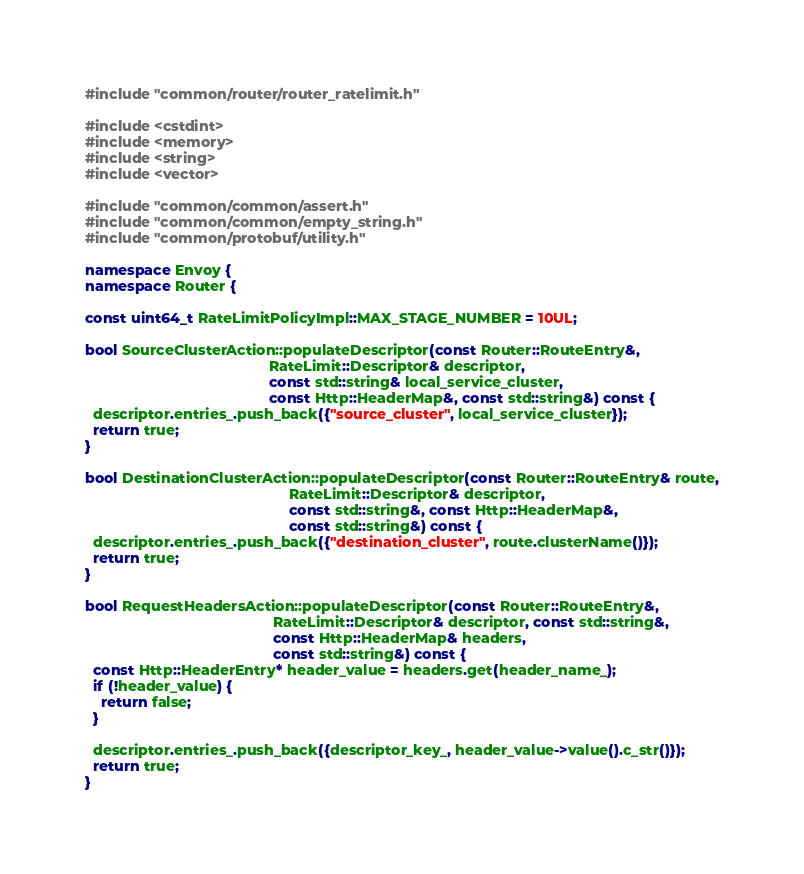Convert code to text. <code><loc_0><loc_0><loc_500><loc_500><_C++_>#include "common/router/router_ratelimit.h"

#include <cstdint>
#include <memory>
#include <string>
#include <vector>

#include "common/common/assert.h"
#include "common/common/empty_string.h"
#include "common/protobuf/utility.h"

namespace Envoy {
namespace Router {

const uint64_t RateLimitPolicyImpl::MAX_STAGE_NUMBER = 10UL;

bool SourceClusterAction::populateDescriptor(const Router::RouteEntry&,
                                             RateLimit::Descriptor& descriptor,
                                             const std::string& local_service_cluster,
                                             const Http::HeaderMap&, const std::string&) const {
  descriptor.entries_.push_back({"source_cluster", local_service_cluster});
  return true;
}

bool DestinationClusterAction::populateDescriptor(const Router::RouteEntry& route,
                                                  RateLimit::Descriptor& descriptor,
                                                  const std::string&, const Http::HeaderMap&,
                                                  const std::string&) const {
  descriptor.entries_.push_back({"destination_cluster", route.clusterName()});
  return true;
}

bool RequestHeadersAction::populateDescriptor(const Router::RouteEntry&,
                                              RateLimit::Descriptor& descriptor, const std::string&,
                                              const Http::HeaderMap& headers,
                                              const std::string&) const {
  const Http::HeaderEntry* header_value = headers.get(header_name_);
  if (!header_value) {
    return false;
  }

  descriptor.entries_.push_back({descriptor_key_, header_value->value().c_str()});
  return true;
}
</code> 